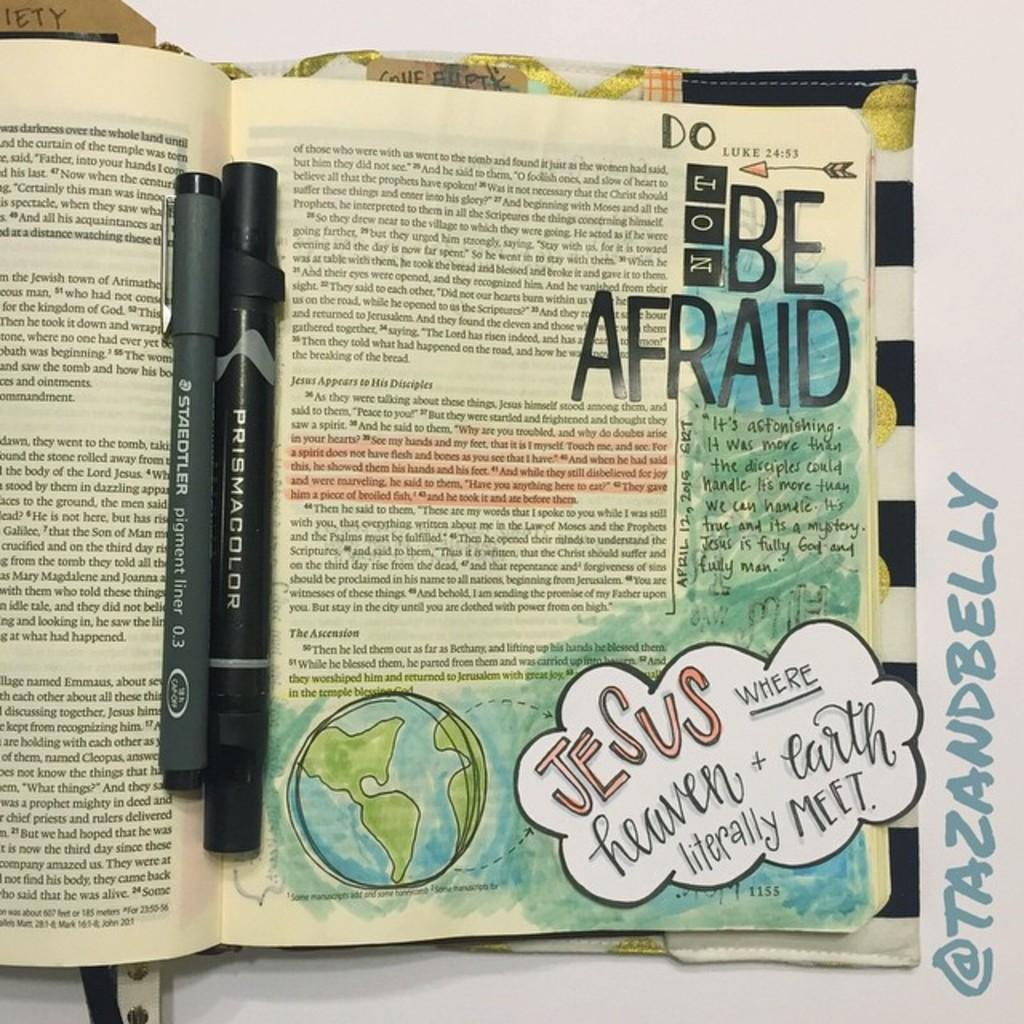<image>
Relay a brief, clear account of the picture shown. the words be afraid are on the page of text 